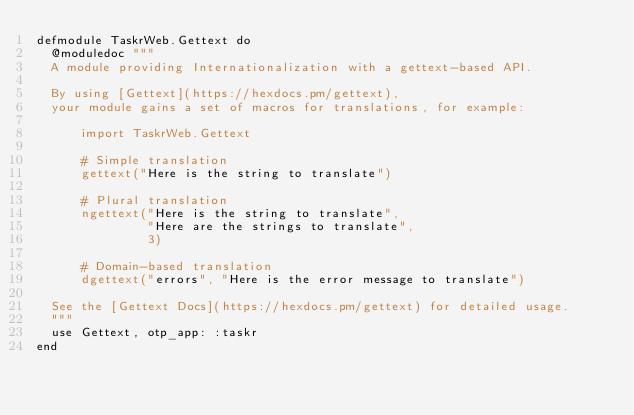<code> <loc_0><loc_0><loc_500><loc_500><_Elixir_>defmodule TaskrWeb.Gettext do
  @moduledoc """
  A module providing Internationalization with a gettext-based API.

  By using [Gettext](https://hexdocs.pm/gettext),
  your module gains a set of macros for translations, for example:

      import TaskrWeb.Gettext

      # Simple translation
      gettext("Here is the string to translate")

      # Plural translation
      ngettext("Here is the string to translate",
               "Here are the strings to translate",
               3)

      # Domain-based translation
      dgettext("errors", "Here is the error message to translate")

  See the [Gettext Docs](https://hexdocs.pm/gettext) for detailed usage.
  """
  use Gettext, otp_app: :taskr
end
</code> 